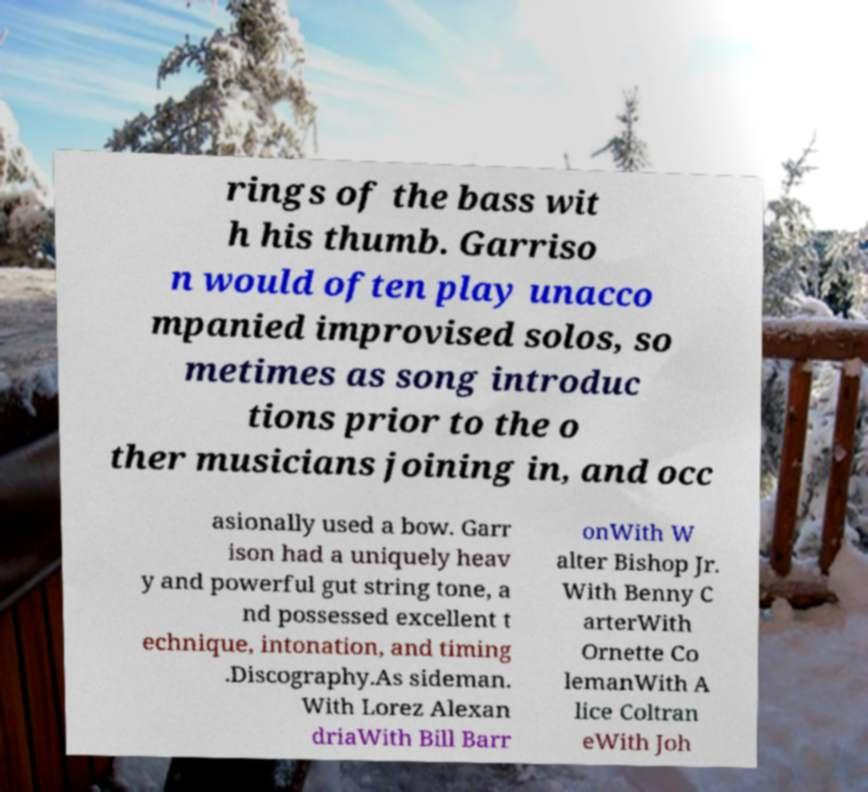Please identify and transcribe the text found in this image. rings of the bass wit h his thumb. Garriso n would often play unacco mpanied improvised solos, so metimes as song introduc tions prior to the o ther musicians joining in, and occ asionally used a bow. Garr ison had a uniquely heav y and powerful gut string tone, a nd possessed excellent t echnique, intonation, and timing .Discography.As sideman. With Lorez Alexan driaWith Bill Barr onWith W alter Bishop Jr. With Benny C arterWith Ornette Co lemanWith A lice Coltran eWith Joh 